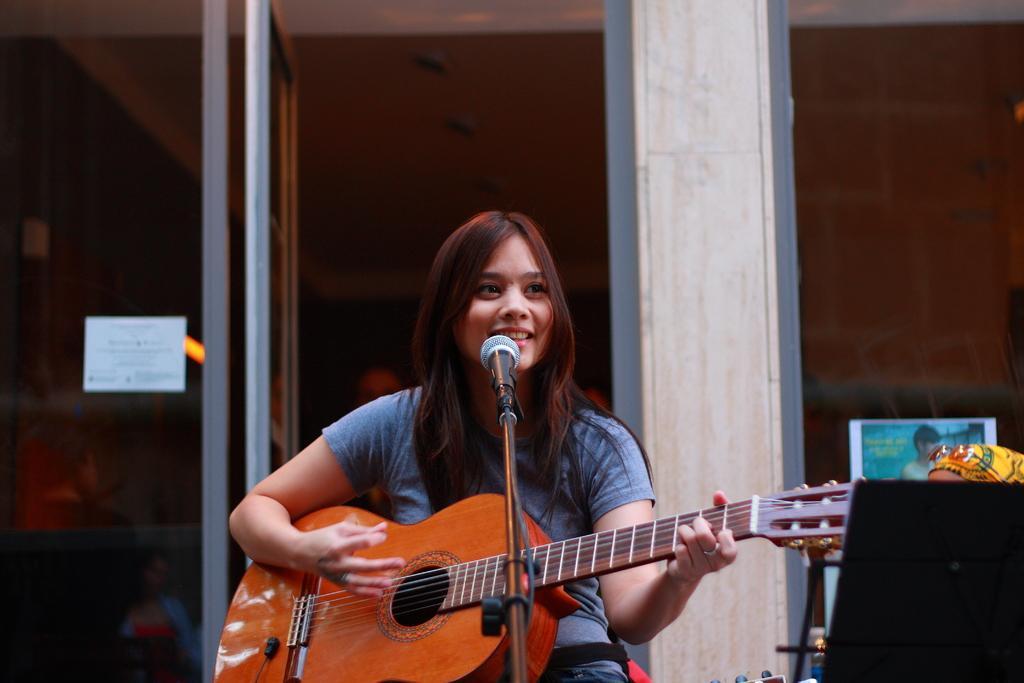Could you give a brief overview of what you see in this image? In this picture there is a girl sitting and smiling and she is playing guitar. At the back there is a door. There is a microphone in front of the girl. 